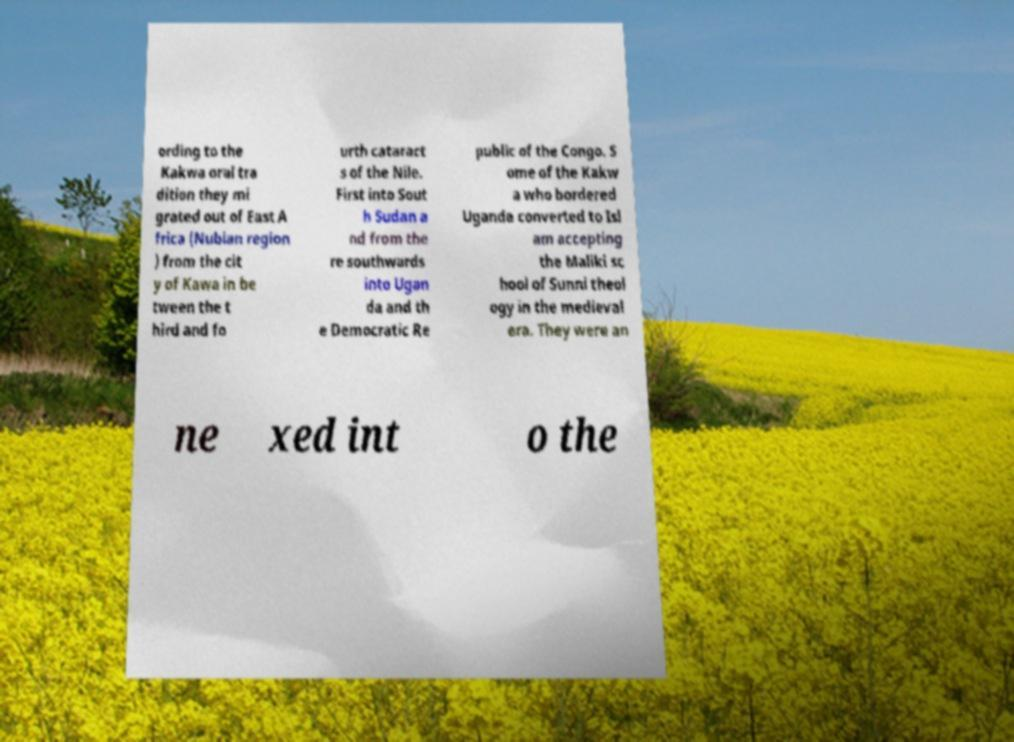I need the written content from this picture converted into text. Can you do that? ording to the Kakwa oral tra dition they mi grated out of East A frica (Nubian region ) from the cit y of Kawa in be tween the t hird and fo urth cataract s of the Nile. First into Sout h Sudan a nd from the re southwards into Ugan da and th e Democratic Re public of the Congo. S ome of the Kakw a who bordered Uganda converted to Isl am accepting the Maliki sc hool of Sunni theol ogy in the medieval era. They were an ne xed int o the 